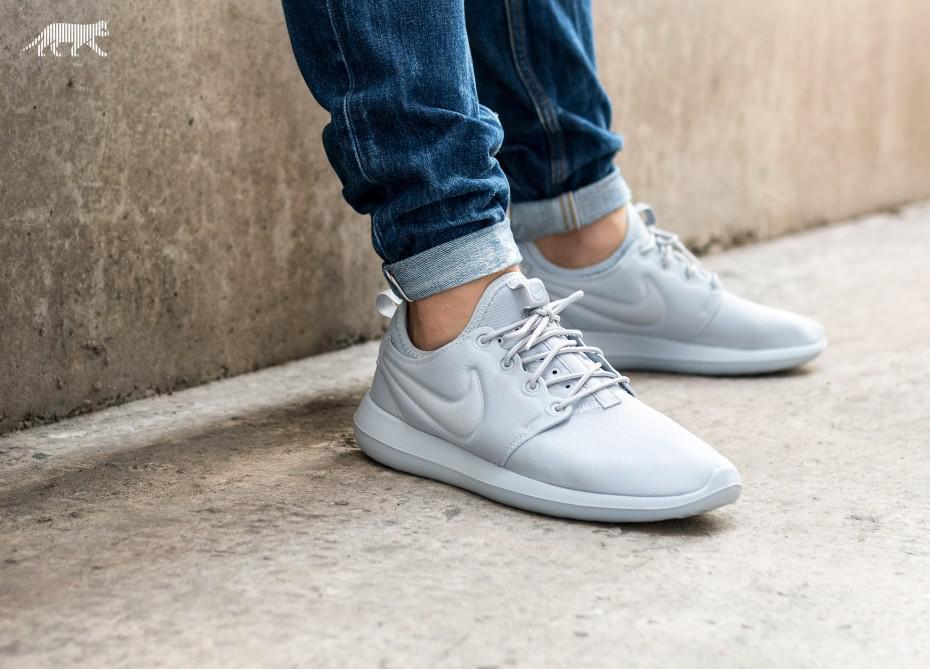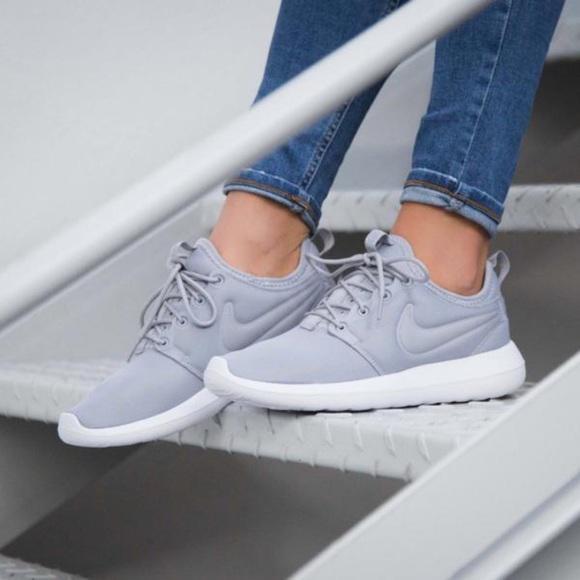The first image is the image on the left, the second image is the image on the right. For the images shown, is this caption "Both images show a pair of grey sneakers that aren't currently worn by anyone." true? Answer yes or no. No. The first image is the image on the left, the second image is the image on the right. Evaluate the accuracy of this statement regarding the images: "Each image contains one unworn, matched pair of sneakers posed soles-downward, and the sneakers in the left and right images face inward toward each other.". Is it true? Answer yes or no. No. 